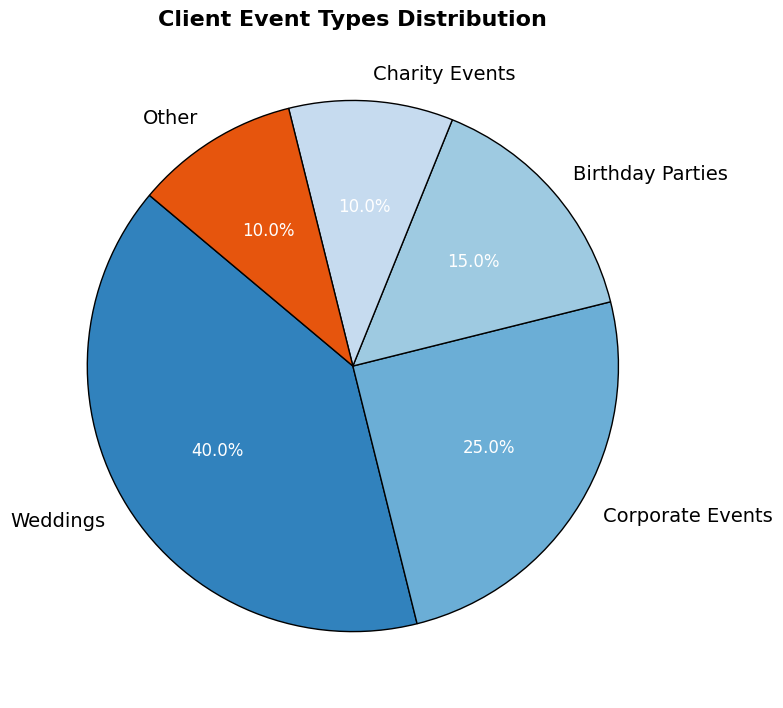What's the total percentage of events that are not weddings? To find the total percentage of events that are not weddings, subtract the percentage of weddings from 100%. So, 100% - 40% = 60%.
Answer: 60 Which event type has the smallest percentage? By inspecting the pie chart, it is apparent that both Charity Events and Other each have the smallest individual percentages at 10%.
Answer: Charity Events, Other How many times larger is the percentage of weddings compared to birthday parties? The percentage of weddings is 40% and birthday parties is 15%. Divide the percentage of weddings by the percentage of birthday parties: 40% / 15% ≈ 2.67.
Answer: 2.67 What is the combined percentage of weddings and corporate events? Add the percentage of weddings (40%) to the percentage of corporate events (25%): 40% + 25% = 65%.
Answer: 65 Which event types constitute exactly 10% of the total each? From the pie chart, the event types Charity Events and Other each make up exactly 10%.
Answer: Charity Events, Other What’s the difference between the percentage of corporate events and birthday parties? Subtract the percentage of birthday parties (15%) from the percentage of corporate events (25%): 25% - 15% = 10%.
Answer: 10 How does the percentage of charity events compare to corporate events? The percentage of charity events is 10%, while corporate events account for 25%, making charity events 15 percentage points less than corporate events.
Answer: Charity events are 15 percentage points less What percentage of events are personal celebrations (weddings and birthday parties combined)? Sum the percentages of weddings (40%) and birthday parties (15%): 40% + 15% = 55%.
Answer: 55 Is the combined percentage of charity events and other events greater than that of corporate events? Sum the percentages of charity events (10%) and other events (10%): 10% + 10% = 20%. Then compare this to the percentage of corporate events (25%). Since 20% < 25%, the combined percentage is not greater.
Answer: No Which event type has the highest percentage? By examining the pie chart, it's clear that weddings have the highest percentage at 40%.
Answer: Weddings 